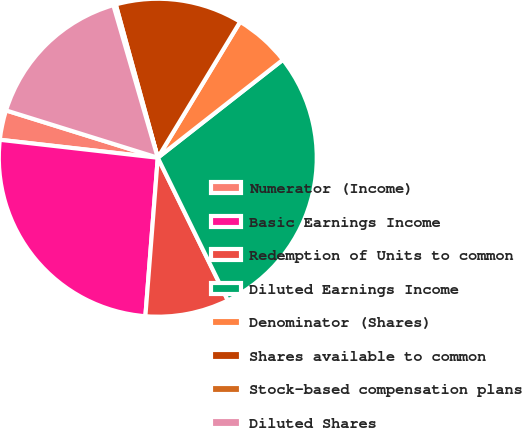Convert chart. <chart><loc_0><loc_0><loc_500><loc_500><pie_chart><fcel>Numerator (Income)<fcel>Basic Earnings Income<fcel>Redemption of Units to common<fcel>Diluted Earnings Income<fcel>Denominator (Shares)<fcel>Shares available to common<fcel>Stock-based compensation plans<fcel>Diluted Shares<nl><fcel>3.01%<fcel>25.56%<fcel>8.51%<fcel>28.31%<fcel>5.76%<fcel>12.93%<fcel>0.25%<fcel>15.68%<nl></chart> 